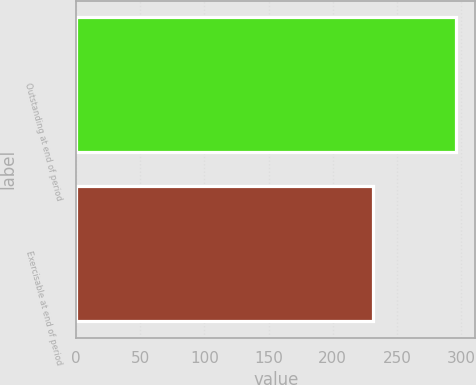Convert chart to OTSL. <chart><loc_0><loc_0><loc_500><loc_500><bar_chart><fcel>Outstanding at end of period<fcel>Exercisable at end of period<nl><fcel>296.41<fcel>231.5<nl></chart> 